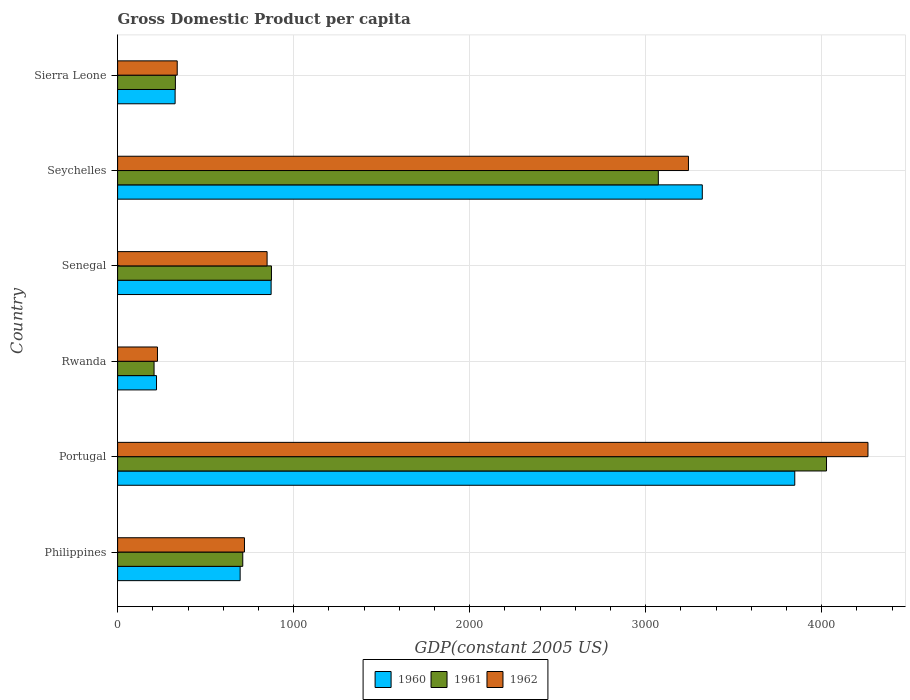How many different coloured bars are there?
Your answer should be very brief. 3. How many groups of bars are there?
Your response must be concise. 6. Are the number of bars per tick equal to the number of legend labels?
Offer a terse response. Yes. Are the number of bars on each tick of the Y-axis equal?
Your answer should be compact. Yes. How many bars are there on the 2nd tick from the bottom?
Your answer should be very brief. 3. What is the label of the 5th group of bars from the top?
Your answer should be very brief. Portugal. What is the GDP per capita in 1961 in Portugal?
Provide a succinct answer. 4027.06. Across all countries, what is the maximum GDP per capita in 1961?
Offer a terse response. 4027.06. Across all countries, what is the minimum GDP per capita in 1961?
Make the answer very short. 207.07. In which country was the GDP per capita in 1961 maximum?
Offer a very short reply. Portugal. In which country was the GDP per capita in 1962 minimum?
Your answer should be compact. Rwanda. What is the total GDP per capita in 1962 in the graph?
Provide a succinct answer. 9640.1. What is the difference between the GDP per capita in 1960 in Seychelles and that in Sierra Leone?
Give a very brief answer. 2994.74. What is the difference between the GDP per capita in 1961 in Seychelles and the GDP per capita in 1960 in Portugal?
Make the answer very short. -775.08. What is the average GDP per capita in 1961 per country?
Keep it short and to the point. 1536.49. What is the difference between the GDP per capita in 1960 and GDP per capita in 1962 in Rwanda?
Make the answer very short. -5.43. In how many countries, is the GDP per capita in 1962 greater than 3400 US$?
Give a very brief answer. 1. What is the ratio of the GDP per capita in 1960 in Philippines to that in Sierra Leone?
Your response must be concise. 2.13. What is the difference between the highest and the second highest GDP per capita in 1961?
Offer a very short reply. 955.44. What is the difference between the highest and the lowest GDP per capita in 1960?
Give a very brief answer. 3625.72. In how many countries, is the GDP per capita in 1960 greater than the average GDP per capita in 1960 taken over all countries?
Your answer should be very brief. 2. Is the sum of the GDP per capita in 1960 in Philippines and Senegal greater than the maximum GDP per capita in 1962 across all countries?
Offer a terse response. No. What does the 1st bar from the top in Portugal represents?
Keep it short and to the point. 1962. Is it the case that in every country, the sum of the GDP per capita in 1961 and GDP per capita in 1960 is greater than the GDP per capita in 1962?
Give a very brief answer. Yes. How many bars are there?
Make the answer very short. 18. What is the difference between two consecutive major ticks on the X-axis?
Provide a succinct answer. 1000. Are the values on the major ticks of X-axis written in scientific E-notation?
Your answer should be compact. No. Does the graph contain grids?
Your answer should be very brief. Yes. How many legend labels are there?
Your answer should be compact. 3. How are the legend labels stacked?
Ensure brevity in your answer.  Horizontal. What is the title of the graph?
Give a very brief answer. Gross Domestic Product per capita. What is the label or title of the X-axis?
Offer a very short reply. GDP(constant 2005 US). What is the GDP(constant 2005 US) in 1960 in Philippines?
Offer a very short reply. 696.02. What is the GDP(constant 2005 US) of 1961 in Philippines?
Offer a terse response. 710.98. What is the GDP(constant 2005 US) in 1962 in Philippines?
Your response must be concise. 720.61. What is the GDP(constant 2005 US) in 1960 in Portugal?
Provide a short and direct response. 3846.7. What is the GDP(constant 2005 US) in 1961 in Portugal?
Your answer should be compact. 4027.06. What is the GDP(constant 2005 US) of 1962 in Portugal?
Make the answer very short. 4262.56. What is the GDP(constant 2005 US) of 1960 in Rwanda?
Offer a very short reply. 220.99. What is the GDP(constant 2005 US) in 1961 in Rwanda?
Give a very brief answer. 207.07. What is the GDP(constant 2005 US) of 1962 in Rwanda?
Ensure brevity in your answer.  226.42. What is the GDP(constant 2005 US) in 1960 in Senegal?
Offer a terse response. 872.05. What is the GDP(constant 2005 US) in 1961 in Senegal?
Provide a short and direct response. 873.95. What is the GDP(constant 2005 US) in 1962 in Senegal?
Your answer should be compact. 849.14. What is the GDP(constant 2005 US) of 1960 in Seychelles?
Offer a terse response. 3321.36. What is the GDP(constant 2005 US) of 1961 in Seychelles?
Keep it short and to the point. 3071.62. What is the GDP(constant 2005 US) of 1962 in Seychelles?
Your response must be concise. 3242.73. What is the GDP(constant 2005 US) in 1960 in Sierra Leone?
Your response must be concise. 326.63. What is the GDP(constant 2005 US) in 1961 in Sierra Leone?
Make the answer very short. 328.25. What is the GDP(constant 2005 US) of 1962 in Sierra Leone?
Provide a short and direct response. 338.65. Across all countries, what is the maximum GDP(constant 2005 US) in 1960?
Your answer should be compact. 3846.7. Across all countries, what is the maximum GDP(constant 2005 US) of 1961?
Your answer should be compact. 4027.06. Across all countries, what is the maximum GDP(constant 2005 US) of 1962?
Ensure brevity in your answer.  4262.56. Across all countries, what is the minimum GDP(constant 2005 US) of 1960?
Give a very brief answer. 220.99. Across all countries, what is the minimum GDP(constant 2005 US) of 1961?
Provide a succinct answer. 207.07. Across all countries, what is the minimum GDP(constant 2005 US) in 1962?
Ensure brevity in your answer.  226.42. What is the total GDP(constant 2005 US) of 1960 in the graph?
Offer a very short reply. 9283.76. What is the total GDP(constant 2005 US) of 1961 in the graph?
Provide a short and direct response. 9218.95. What is the total GDP(constant 2005 US) in 1962 in the graph?
Keep it short and to the point. 9640.1. What is the difference between the GDP(constant 2005 US) of 1960 in Philippines and that in Portugal?
Your response must be concise. -3150.68. What is the difference between the GDP(constant 2005 US) of 1961 in Philippines and that in Portugal?
Provide a short and direct response. -3316.08. What is the difference between the GDP(constant 2005 US) of 1962 in Philippines and that in Portugal?
Give a very brief answer. -3541.95. What is the difference between the GDP(constant 2005 US) in 1960 in Philippines and that in Rwanda?
Your answer should be compact. 475.03. What is the difference between the GDP(constant 2005 US) in 1961 in Philippines and that in Rwanda?
Offer a terse response. 503.92. What is the difference between the GDP(constant 2005 US) of 1962 in Philippines and that in Rwanda?
Provide a short and direct response. 494.19. What is the difference between the GDP(constant 2005 US) of 1960 in Philippines and that in Senegal?
Offer a very short reply. -176.03. What is the difference between the GDP(constant 2005 US) of 1961 in Philippines and that in Senegal?
Provide a short and direct response. -162.97. What is the difference between the GDP(constant 2005 US) of 1962 in Philippines and that in Senegal?
Ensure brevity in your answer.  -128.53. What is the difference between the GDP(constant 2005 US) in 1960 in Philippines and that in Seychelles?
Your answer should be very brief. -2625.34. What is the difference between the GDP(constant 2005 US) in 1961 in Philippines and that in Seychelles?
Provide a succinct answer. -2360.64. What is the difference between the GDP(constant 2005 US) of 1962 in Philippines and that in Seychelles?
Give a very brief answer. -2522.12. What is the difference between the GDP(constant 2005 US) of 1960 in Philippines and that in Sierra Leone?
Offer a terse response. 369.39. What is the difference between the GDP(constant 2005 US) in 1961 in Philippines and that in Sierra Leone?
Your answer should be very brief. 382.73. What is the difference between the GDP(constant 2005 US) of 1962 in Philippines and that in Sierra Leone?
Provide a succinct answer. 381.95. What is the difference between the GDP(constant 2005 US) of 1960 in Portugal and that in Rwanda?
Offer a very short reply. 3625.72. What is the difference between the GDP(constant 2005 US) of 1961 in Portugal and that in Rwanda?
Offer a terse response. 3820. What is the difference between the GDP(constant 2005 US) of 1962 in Portugal and that in Rwanda?
Keep it short and to the point. 4036.14. What is the difference between the GDP(constant 2005 US) of 1960 in Portugal and that in Senegal?
Offer a terse response. 2974.65. What is the difference between the GDP(constant 2005 US) of 1961 in Portugal and that in Senegal?
Give a very brief answer. 3153.11. What is the difference between the GDP(constant 2005 US) in 1962 in Portugal and that in Senegal?
Ensure brevity in your answer.  3413.42. What is the difference between the GDP(constant 2005 US) of 1960 in Portugal and that in Seychelles?
Offer a very short reply. 525.34. What is the difference between the GDP(constant 2005 US) in 1961 in Portugal and that in Seychelles?
Make the answer very short. 955.44. What is the difference between the GDP(constant 2005 US) of 1962 in Portugal and that in Seychelles?
Keep it short and to the point. 1019.83. What is the difference between the GDP(constant 2005 US) of 1960 in Portugal and that in Sierra Leone?
Offer a terse response. 3520.07. What is the difference between the GDP(constant 2005 US) in 1961 in Portugal and that in Sierra Leone?
Make the answer very short. 3698.81. What is the difference between the GDP(constant 2005 US) of 1962 in Portugal and that in Sierra Leone?
Your response must be concise. 3923.91. What is the difference between the GDP(constant 2005 US) in 1960 in Rwanda and that in Senegal?
Offer a terse response. -651.07. What is the difference between the GDP(constant 2005 US) in 1961 in Rwanda and that in Senegal?
Your answer should be compact. -666.89. What is the difference between the GDP(constant 2005 US) in 1962 in Rwanda and that in Senegal?
Ensure brevity in your answer.  -622.72. What is the difference between the GDP(constant 2005 US) of 1960 in Rwanda and that in Seychelles?
Offer a terse response. -3100.38. What is the difference between the GDP(constant 2005 US) of 1961 in Rwanda and that in Seychelles?
Your answer should be compact. -2864.56. What is the difference between the GDP(constant 2005 US) of 1962 in Rwanda and that in Seychelles?
Your response must be concise. -3016.31. What is the difference between the GDP(constant 2005 US) in 1960 in Rwanda and that in Sierra Leone?
Ensure brevity in your answer.  -105.64. What is the difference between the GDP(constant 2005 US) in 1961 in Rwanda and that in Sierra Leone?
Give a very brief answer. -121.19. What is the difference between the GDP(constant 2005 US) in 1962 in Rwanda and that in Sierra Leone?
Your response must be concise. -112.24. What is the difference between the GDP(constant 2005 US) in 1960 in Senegal and that in Seychelles?
Ensure brevity in your answer.  -2449.31. What is the difference between the GDP(constant 2005 US) of 1961 in Senegal and that in Seychelles?
Make the answer very short. -2197.67. What is the difference between the GDP(constant 2005 US) in 1962 in Senegal and that in Seychelles?
Provide a short and direct response. -2393.59. What is the difference between the GDP(constant 2005 US) in 1960 in Senegal and that in Sierra Leone?
Keep it short and to the point. 545.42. What is the difference between the GDP(constant 2005 US) of 1961 in Senegal and that in Sierra Leone?
Give a very brief answer. 545.7. What is the difference between the GDP(constant 2005 US) of 1962 in Senegal and that in Sierra Leone?
Your answer should be very brief. 510.48. What is the difference between the GDP(constant 2005 US) in 1960 in Seychelles and that in Sierra Leone?
Offer a very short reply. 2994.74. What is the difference between the GDP(constant 2005 US) in 1961 in Seychelles and that in Sierra Leone?
Your response must be concise. 2743.37. What is the difference between the GDP(constant 2005 US) of 1962 in Seychelles and that in Sierra Leone?
Give a very brief answer. 2904.08. What is the difference between the GDP(constant 2005 US) of 1960 in Philippines and the GDP(constant 2005 US) of 1961 in Portugal?
Your response must be concise. -3331.04. What is the difference between the GDP(constant 2005 US) in 1960 in Philippines and the GDP(constant 2005 US) in 1962 in Portugal?
Your answer should be compact. -3566.54. What is the difference between the GDP(constant 2005 US) of 1961 in Philippines and the GDP(constant 2005 US) of 1962 in Portugal?
Your response must be concise. -3551.57. What is the difference between the GDP(constant 2005 US) of 1960 in Philippines and the GDP(constant 2005 US) of 1961 in Rwanda?
Provide a short and direct response. 488.95. What is the difference between the GDP(constant 2005 US) in 1960 in Philippines and the GDP(constant 2005 US) in 1962 in Rwanda?
Your answer should be very brief. 469.6. What is the difference between the GDP(constant 2005 US) in 1961 in Philippines and the GDP(constant 2005 US) in 1962 in Rwanda?
Keep it short and to the point. 484.57. What is the difference between the GDP(constant 2005 US) in 1960 in Philippines and the GDP(constant 2005 US) in 1961 in Senegal?
Your answer should be very brief. -177.93. What is the difference between the GDP(constant 2005 US) in 1960 in Philippines and the GDP(constant 2005 US) in 1962 in Senegal?
Provide a succinct answer. -153.12. What is the difference between the GDP(constant 2005 US) in 1961 in Philippines and the GDP(constant 2005 US) in 1962 in Senegal?
Give a very brief answer. -138.15. What is the difference between the GDP(constant 2005 US) in 1960 in Philippines and the GDP(constant 2005 US) in 1961 in Seychelles?
Offer a terse response. -2375.6. What is the difference between the GDP(constant 2005 US) of 1960 in Philippines and the GDP(constant 2005 US) of 1962 in Seychelles?
Keep it short and to the point. -2546.71. What is the difference between the GDP(constant 2005 US) of 1961 in Philippines and the GDP(constant 2005 US) of 1962 in Seychelles?
Your answer should be very brief. -2531.74. What is the difference between the GDP(constant 2005 US) of 1960 in Philippines and the GDP(constant 2005 US) of 1961 in Sierra Leone?
Your response must be concise. 367.77. What is the difference between the GDP(constant 2005 US) of 1960 in Philippines and the GDP(constant 2005 US) of 1962 in Sierra Leone?
Keep it short and to the point. 357.37. What is the difference between the GDP(constant 2005 US) in 1961 in Philippines and the GDP(constant 2005 US) in 1962 in Sierra Leone?
Provide a succinct answer. 372.33. What is the difference between the GDP(constant 2005 US) of 1960 in Portugal and the GDP(constant 2005 US) of 1961 in Rwanda?
Give a very brief answer. 3639.64. What is the difference between the GDP(constant 2005 US) in 1960 in Portugal and the GDP(constant 2005 US) in 1962 in Rwanda?
Your response must be concise. 3620.29. What is the difference between the GDP(constant 2005 US) in 1961 in Portugal and the GDP(constant 2005 US) in 1962 in Rwanda?
Keep it short and to the point. 3800.65. What is the difference between the GDP(constant 2005 US) in 1960 in Portugal and the GDP(constant 2005 US) in 1961 in Senegal?
Provide a short and direct response. 2972.75. What is the difference between the GDP(constant 2005 US) in 1960 in Portugal and the GDP(constant 2005 US) in 1962 in Senegal?
Ensure brevity in your answer.  2997.57. What is the difference between the GDP(constant 2005 US) in 1961 in Portugal and the GDP(constant 2005 US) in 1962 in Senegal?
Keep it short and to the point. 3177.93. What is the difference between the GDP(constant 2005 US) in 1960 in Portugal and the GDP(constant 2005 US) in 1961 in Seychelles?
Give a very brief answer. 775.08. What is the difference between the GDP(constant 2005 US) in 1960 in Portugal and the GDP(constant 2005 US) in 1962 in Seychelles?
Make the answer very short. 603.97. What is the difference between the GDP(constant 2005 US) of 1961 in Portugal and the GDP(constant 2005 US) of 1962 in Seychelles?
Provide a short and direct response. 784.33. What is the difference between the GDP(constant 2005 US) in 1960 in Portugal and the GDP(constant 2005 US) in 1961 in Sierra Leone?
Ensure brevity in your answer.  3518.45. What is the difference between the GDP(constant 2005 US) in 1960 in Portugal and the GDP(constant 2005 US) in 1962 in Sierra Leone?
Offer a terse response. 3508.05. What is the difference between the GDP(constant 2005 US) of 1961 in Portugal and the GDP(constant 2005 US) of 1962 in Sierra Leone?
Your answer should be compact. 3688.41. What is the difference between the GDP(constant 2005 US) of 1960 in Rwanda and the GDP(constant 2005 US) of 1961 in Senegal?
Provide a short and direct response. -652.97. What is the difference between the GDP(constant 2005 US) of 1960 in Rwanda and the GDP(constant 2005 US) of 1962 in Senegal?
Your answer should be compact. -628.15. What is the difference between the GDP(constant 2005 US) in 1961 in Rwanda and the GDP(constant 2005 US) in 1962 in Senegal?
Offer a terse response. -642.07. What is the difference between the GDP(constant 2005 US) in 1960 in Rwanda and the GDP(constant 2005 US) in 1961 in Seychelles?
Keep it short and to the point. -2850.64. What is the difference between the GDP(constant 2005 US) of 1960 in Rwanda and the GDP(constant 2005 US) of 1962 in Seychelles?
Offer a very short reply. -3021.74. What is the difference between the GDP(constant 2005 US) in 1961 in Rwanda and the GDP(constant 2005 US) in 1962 in Seychelles?
Your response must be concise. -3035.66. What is the difference between the GDP(constant 2005 US) of 1960 in Rwanda and the GDP(constant 2005 US) of 1961 in Sierra Leone?
Your response must be concise. -107.27. What is the difference between the GDP(constant 2005 US) in 1960 in Rwanda and the GDP(constant 2005 US) in 1962 in Sierra Leone?
Your answer should be compact. -117.67. What is the difference between the GDP(constant 2005 US) in 1961 in Rwanda and the GDP(constant 2005 US) in 1962 in Sierra Leone?
Offer a terse response. -131.59. What is the difference between the GDP(constant 2005 US) in 1960 in Senegal and the GDP(constant 2005 US) in 1961 in Seychelles?
Give a very brief answer. -2199.57. What is the difference between the GDP(constant 2005 US) of 1960 in Senegal and the GDP(constant 2005 US) of 1962 in Seychelles?
Provide a succinct answer. -2370.68. What is the difference between the GDP(constant 2005 US) in 1961 in Senegal and the GDP(constant 2005 US) in 1962 in Seychelles?
Make the answer very short. -2368.78. What is the difference between the GDP(constant 2005 US) of 1960 in Senegal and the GDP(constant 2005 US) of 1961 in Sierra Leone?
Provide a short and direct response. 543.8. What is the difference between the GDP(constant 2005 US) of 1960 in Senegal and the GDP(constant 2005 US) of 1962 in Sierra Leone?
Give a very brief answer. 533.4. What is the difference between the GDP(constant 2005 US) of 1961 in Senegal and the GDP(constant 2005 US) of 1962 in Sierra Leone?
Ensure brevity in your answer.  535.3. What is the difference between the GDP(constant 2005 US) of 1960 in Seychelles and the GDP(constant 2005 US) of 1961 in Sierra Leone?
Your answer should be very brief. 2993.11. What is the difference between the GDP(constant 2005 US) of 1960 in Seychelles and the GDP(constant 2005 US) of 1962 in Sierra Leone?
Give a very brief answer. 2982.71. What is the difference between the GDP(constant 2005 US) of 1961 in Seychelles and the GDP(constant 2005 US) of 1962 in Sierra Leone?
Your answer should be compact. 2732.97. What is the average GDP(constant 2005 US) of 1960 per country?
Make the answer very short. 1547.29. What is the average GDP(constant 2005 US) in 1961 per country?
Your answer should be compact. 1536.49. What is the average GDP(constant 2005 US) of 1962 per country?
Your answer should be very brief. 1606.68. What is the difference between the GDP(constant 2005 US) of 1960 and GDP(constant 2005 US) of 1961 in Philippines?
Make the answer very short. -14.96. What is the difference between the GDP(constant 2005 US) of 1960 and GDP(constant 2005 US) of 1962 in Philippines?
Keep it short and to the point. -24.59. What is the difference between the GDP(constant 2005 US) of 1961 and GDP(constant 2005 US) of 1962 in Philippines?
Provide a short and direct response. -9.62. What is the difference between the GDP(constant 2005 US) in 1960 and GDP(constant 2005 US) in 1961 in Portugal?
Offer a terse response. -180.36. What is the difference between the GDP(constant 2005 US) in 1960 and GDP(constant 2005 US) in 1962 in Portugal?
Provide a short and direct response. -415.86. What is the difference between the GDP(constant 2005 US) of 1961 and GDP(constant 2005 US) of 1962 in Portugal?
Make the answer very short. -235.5. What is the difference between the GDP(constant 2005 US) in 1960 and GDP(constant 2005 US) in 1961 in Rwanda?
Your answer should be compact. 13.92. What is the difference between the GDP(constant 2005 US) of 1960 and GDP(constant 2005 US) of 1962 in Rwanda?
Your answer should be compact. -5.43. What is the difference between the GDP(constant 2005 US) of 1961 and GDP(constant 2005 US) of 1962 in Rwanda?
Provide a succinct answer. -19.35. What is the difference between the GDP(constant 2005 US) of 1960 and GDP(constant 2005 US) of 1961 in Senegal?
Provide a short and direct response. -1.9. What is the difference between the GDP(constant 2005 US) of 1960 and GDP(constant 2005 US) of 1962 in Senegal?
Provide a succinct answer. 22.92. What is the difference between the GDP(constant 2005 US) of 1961 and GDP(constant 2005 US) of 1962 in Senegal?
Provide a succinct answer. 24.82. What is the difference between the GDP(constant 2005 US) of 1960 and GDP(constant 2005 US) of 1961 in Seychelles?
Your response must be concise. 249.74. What is the difference between the GDP(constant 2005 US) in 1960 and GDP(constant 2005 US) in 1962 in Seychelles?
Offer a terse response. 78.64. What is the difference between the GDP(constant 2005 US) in 1961 and GDP(constant 2005 US) in 1962 in Seychelles?
Offer a terse response. -171.1. What is the difference between the GDP(constant 2005 US) of 1960 and GDP(constant 2005 US) of 1961 in Sierra Leone?
Provide a succinct answer. -1.63. What is the difference between the GDP(constant 2005 US) of 1960 and GDP(constant 2005 US) of 1962 in Sierra Leone?
Make the answer very short. -12.02. What is the difference between the GDP(constant 2005 US) in 1961 and GDP(constant 2005 US) in 1962 in Sierra Leone?
Give a very brief answer. -10.4. What is the ratio of the GDP(constant 2005 US) of 1960 in Philippines to that in Portugal?
Ensure brevity in your answer.  0.18. What is the ratio of the GDP(constant 2005 US) in 1961 in Philippines to that in Portugal?
Keep it short and to the point. 0.18. What is the ratio of the GDP(constant 2005 US) in 1962 in Philippines to that in Portugal?
Offer a very short reply. 0.17. What is the ratio of the GDP(constant 2005 US) of 1960 in Philippines to that in Rwanda?
Your answer should be compact. 3.15. What is the ratio of the GDP(constant 2005 US) of 1961 in Philippines to that in Rwanda?
Offer a terse response. 3.43. What is the ratio of the GDP(constant 2005 US) in 1962 in Philippines to that in Rwanda?
Your answer should be very brief. 3.18. What is the ratio of the GDP(constant 2005 US) of 1960 in Philippines to that in Senegal?
Offer a very short reply. 0.8. What is the ratio of the GDP(constant 2005 US) of 1961 in Philippines to that in Senegal?
Your answer should be compact. 0.81. What is the ratio of the GDP(constant 2005 US) of 1962 in Philippines to that in Senegal?
Keep it short and to the point. 0.85. What is the ratio of the GDP(constant 2005 US) in 1960 in Philippines to that in Seychelles?
Provide a short and direct response. 0.21. What is the ratio of the GDP(constant 2005 US) in 1961 in Philippines to that in Seychelles?
Offer a very short reply. 0.23. What is the ratio of the GDP(constant 2005 US) in 1962 in Philippines to that in Seychelles?
Offer a terse response. 0.22. What is the ratio of the GDP(constant 2005 US) in 1960 in Philippines to that in Sierra Leone?
Give a very brief answer. 2.13. What is the ratio of the GDP(constant 2005 US) of 1961 in Philippines to that in Sierra Leone?
Your answer should be compact. 2.17. What is the ratio of the GDP(constant 2005 US) in 1962 in Philippines to that in Sierra Leone?
Provide a short and direct response. 2.13. What is the ratio of the GDP(constant 2005 US) in 1960 in Portugal to that in Rwanda?
Offer a terse response. 17.41. What is the ratio of the GDP(constant 2005 US) of 1961 in Portugal to that in Rwanda?
Provide a short and direct response. 19.45. What is the ratio of the GDP(constant 2005 US) in 1962 in Portugal to that in Rwanda?
Give a very brief answer. 18.83. What is the ratio of the GDP(constant 2005 US) of 1960 in Portugal to that in Senegal?
Keep it short and to the point. 4.41. What is the ratio of the GDP(constant 2005 US) in 1961 in Portugal to that in Senegal?
Your answer should be compact. 4.61. What is the ratio of the GDP(constant 2005 US) of 1962 in Portugal to that in Senegal?
Offer a terse response. 5.02. What is the ratio of the GDP(constant 2005 US) of 1960 in Portugal to that in Seychelles?
Make the answer very short. 1.16. What is the ratio of the GDP(constant 2005 US) in 1961 in Portugal to that in Seychelles?
Your answer should be very brief. 1.31. What is the ratio of the GDP(constant 2005 US) of 1962 in Portugal to that in Seychelles?
Your response must be concise. 1.31. What is the ratio of the GDP(constant 2005 US) in 1960 in Portugal to that in Sierra Leone?
Give a very brief answer. 11.78. What is the ratio of the GDP(constant 2005 US) in 1961 in Portugal to that in Sierra Leone?
Provide a succinct answer. 12.27. What is the ratio of the GDP(constant 2005 US) in 1962 in Portugal to that in Sierra Leone?
Your response must be concise. 12.59. What is the ratio of the GDP(constant 2005 US) of 1960 in Rwanda to that in Senegal?
Ensure brevity in your answer.  0.25. What is the ratio of the GDP(constant 2005 US) of 1961 in Rwanda to that in Senegal?
Your answer should be very brief. 0.24. What is the ratio of the GDP(constant 2005 US) in 1962 in Rwanda to that in Senegal?
Offer a terse response. 0.27. What is the ratio of the GDP(constant 2005 US) of 1960 in Rwanda to that in Seychelles?
Ensure brevity in your answer.  0.07. What is the ratio of the GDP(constant 2005 US) in 1961 in Rwanda to that in Seychelles?
Ensure brevity in your answer.  0.07. What is the ratio of the GDP(constant 2005 US) in 1962 in Rwanda to that in Seychelles?
Your response must be concise. 0.07. What is the ratio of the GDP(constant 2005 US) in 1960 in Rwanda to that in Sierra Leone?
Provide a short and direct response. 0.68. What is the ratio of the GDP(constant 2005 US) of 1961 in Rwanda to that in Sierra Leone?
Your response must be concise. 0.63. What is the ratio of the GDP(constant 2005 US) of 1962 in Rwanda to that in Sierra Leone?
Offer a terse response. 0.67. What is the ratio of the GDP(constant 2005 US) of 1960 in Senegal to that in Seychelles?
Your answer should be very brief. 0.26. What is the ratio of the GDP(constant 2005 US) in 1961 in Senegal to that in Seychelles?
Offer a very short reply. 0.28. What is the ratio of the GDP(constant 2005 US) in 1962 in Senegal to that in Seychelles?
Offer a very short reply. 0.26. What is the ratio of the GDP(constant 2005 US) of 1960 in Senegal to that in Sierra Leone?
Keep it short and to the point. 2.67. What is the ratio of the GDP(constant 2005 US) in 1961 in Senegal to that in Sierra Leone?
Offer a very short reply. 2.66. What is the ratio of the GDP(constant 2005 US) of 1962 in Senegal to that in Sierra Leone?
Offer a terse response. 2.51. What is the ratio of the GDP(constant 2005 US) of 1960 in Seychelles to that in Sierra Leone?
Offer a very short reply. 10.17. What is the ratio of the GDP(constant 2005 US) in 1961 in Seychelles to that in Sierra Leone?
Ensure brevity in your answer.  9.36. What is the ratio of the GDP(constant 2005 US) in 1962 in Seychelles to that in Sierra Leone?
Provide a succinct answer. 9.58. What is the difference between the highest and the second highest GDP(constant 2005 US) in 1960?
Provide a succinct answer. 525.34. What is the difference between the highest and the second highest GDP(constant 2005 US) in 1961?
Keep it short and to the point. 955.44. What is the difference between the highest and the second highest GDP(constant 2005 US) of 1962?
Provide a succinct answer. 1019.83. What is the difference between the highest and the lowest GDP(constant 2005 US) of 1960?
Your response must be concise. 3625.72. What is the difference between the highest and the lowest GDP(constant 2005 US) of 1961?
Keep it short and to the point. 3820. What is the difference between the highest and the lowest GDP(constant 2005 US) in 1962?
Your answer should be very brief. 4036.14. 